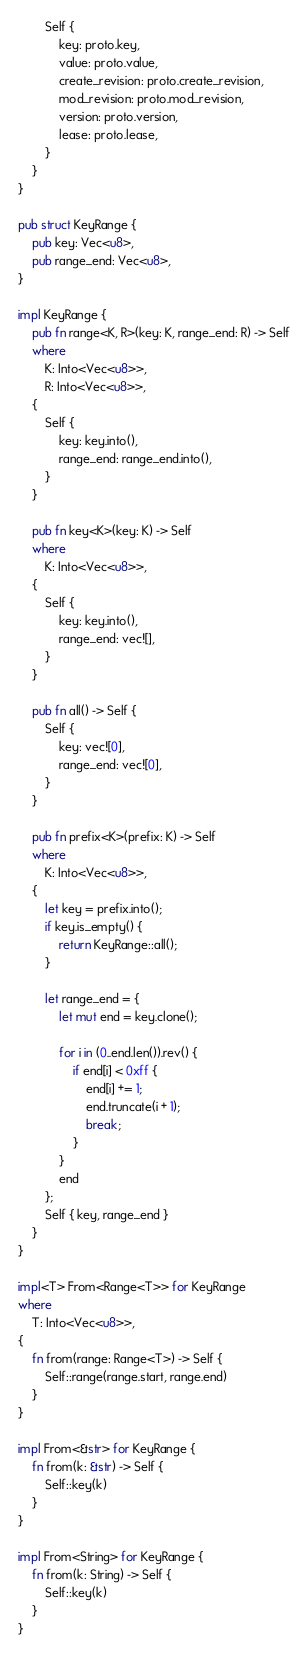Convert code to text. <code><loc_0><loc_0><loc_500><loc_500><_Rust_>        Self {
            key: proto.key,
            value: proto.value,
            create_revision: proto.create_revision,
            mod_revision: proto.mod_revision,
            version: proto.version,
            lease: proto.lease,
        }
    }
}

pub struct KeyRange {
    pub key: Vec<u8>,
    pub range_end: Vec<u8>,
}

impl KeyRange {
    pub fn range<K, R>(key: K, range_end: R) -> Self
    where
        K: Into<Vec<u8>>,
        R: Into<Vec<u8>>,
    {
        Self {
            key: key.into(),
            range_end: range_end.into(),
        }
    }

    pub fn key<K>(key: K) -> Self
    where
        K: Into<Vec<u8>>,
    {
        Self {
            key: key.into(),
            range_end: vec![],
        }
    }

    pub fn all() -> Self {
        Self {
            key: vec![0],
            range_end: vec![0],
        }
    }

    pub fn prefix<K>(prefix: K) -> Self
    where
        K: Into<Vec<u8>>,
    {
        let key = prefix.into();
        if key.is_empty() {
            return KeyRange::all();
        }

        let range_end = {
            let mut end = key.clone();

            for i in (0..end.len()).rev() {
                if end[i] < 0xff {
                    end[i] += 1;
                    end.truncate(i + 1);
                    break;
                }
            }
            end
        };
        Self { key, range_end }
    }
}

impl<T> From<Range<T>> for KeyRange
where
    T: Into<Vec<u8>>,
{
    fn from(range: Range<T>) -> Self {
        Self::range(range.start, range.end)
    }
}

impl From<&str> for KeyRange {
    fn from(k: &str) -> Self {
        Self::key(k)
    }
}

impl From<String> for KeyRange {
    fn from(k: String) -> Self {
        Self::key(k)
    }
}
</code> 